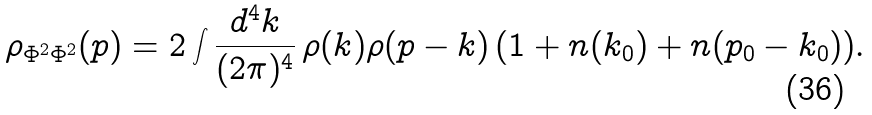<formula> <loc_0><loc_0><loc_500><loc_500>\rho _ { \Phi ^ { 2 } \Phi ^ { 2 } } ( p ) = 2 \int \frac { d ^ { 4 } k } { ( 2 \pi ) ^ { 4 } } \, \rho ( k ) \rho ( p - k ) \, ( 1 + n ( k _ { 0 } ) + n ( p _ { 0 } - k _ { 0 } ) ) .</formula> 